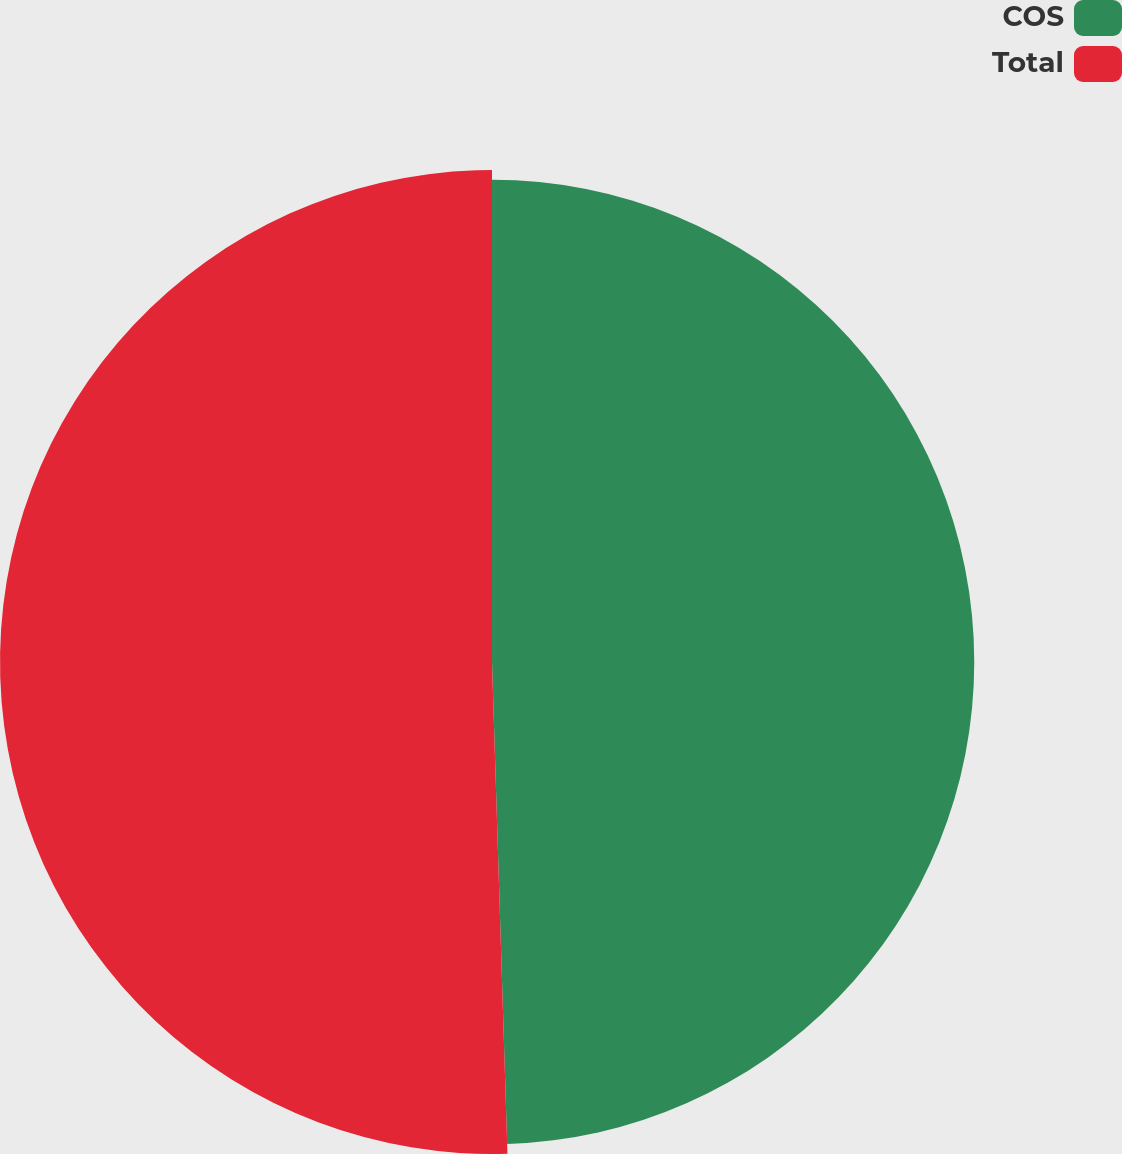Convert chart to OTSL. <chart><loc_0><loc_0><loc_500><loc_500><pie_chart><fcel>COS<fcel>Total<nl><fcel>49.5%<fcel>50.5%<nl></chart> 